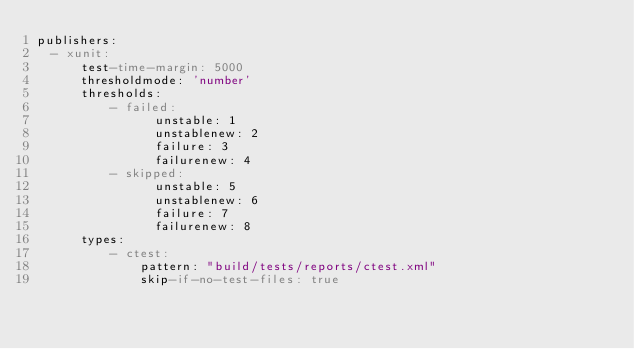Convert code to text. <code><loc_0><loc_0><loc_500><loc_500><_YAML_>publishers:
  - xunit:
      test-time-margin: 5000
      thresholdmode: 'number'
      thresholds:
          - failed:
                unstable: 1
                unstablenew: 2
                failure: 3
                failurenew: 4
          - skipped:
                unstable: 5
                unstablenew: 6
                failure: 7
                failurenew: 8
      types:
          - ctest:
              pattern: "build/tests/reports/ctest.xml"
              skip-if-no-test-files: true
</code> 